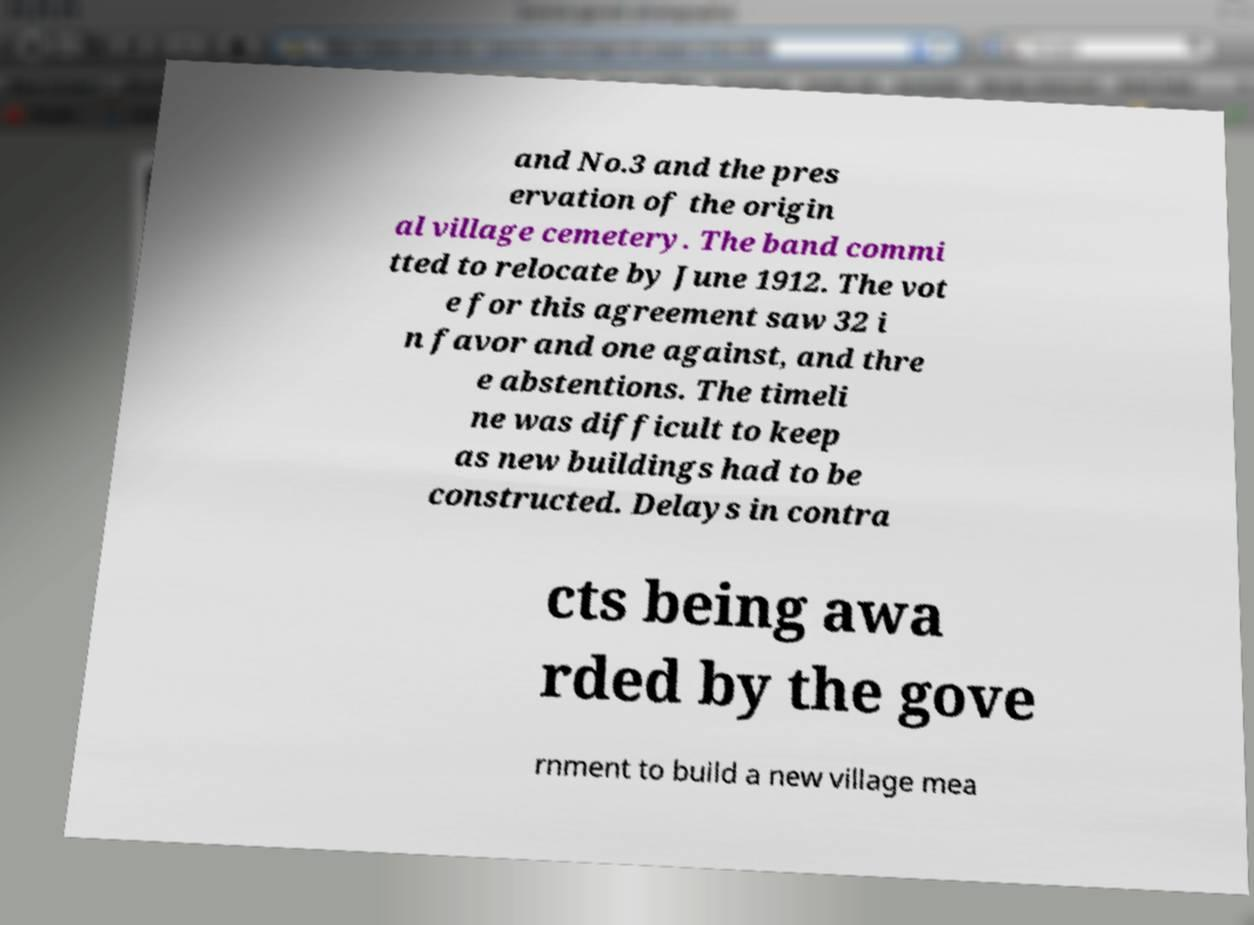Could you extract and type out the text from this image? and No.3 and the pres ervation of the origin al village cemetery. The band commi tted to relocate by June 1912. The vot e for this agreement saw 32 i n favor and one against, and thre e abstentions. The timeli ne was difficult to keep as new buildings had to be constructed. Delays in contra cts being awa rded by the gove rnment to build a new village mea 